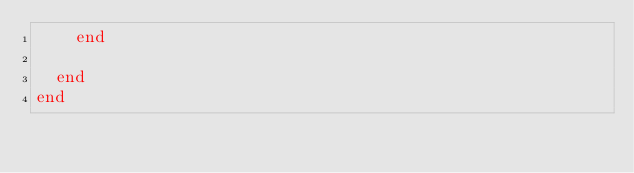Convert code to text. <code><loc_0><loc_0><loc_500><loc_500><_Ruby_>    end

  end
end
</code> 